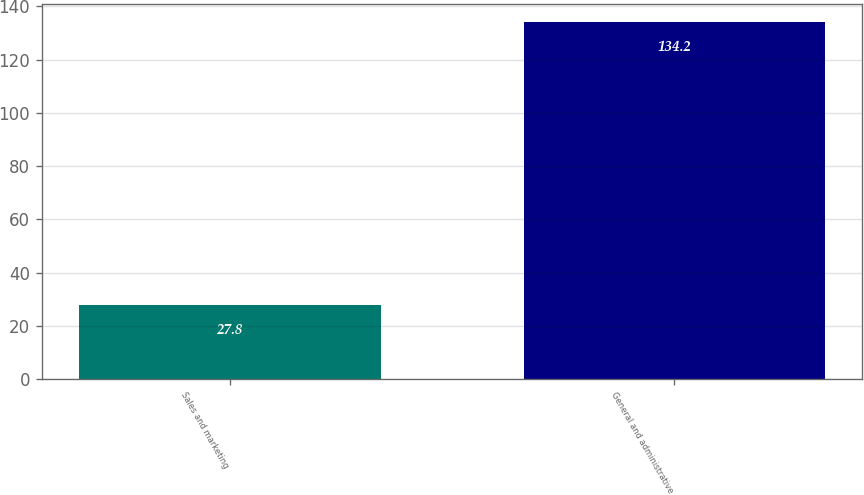Convert chart to OTSL. <chart><loc_0><loc_0><loc_500><loc_500><bar_chart><fcel>Sales and marketing<fcel>General and administrative<nl><fcel>27.8<fcel>134.2<nl></chart> 